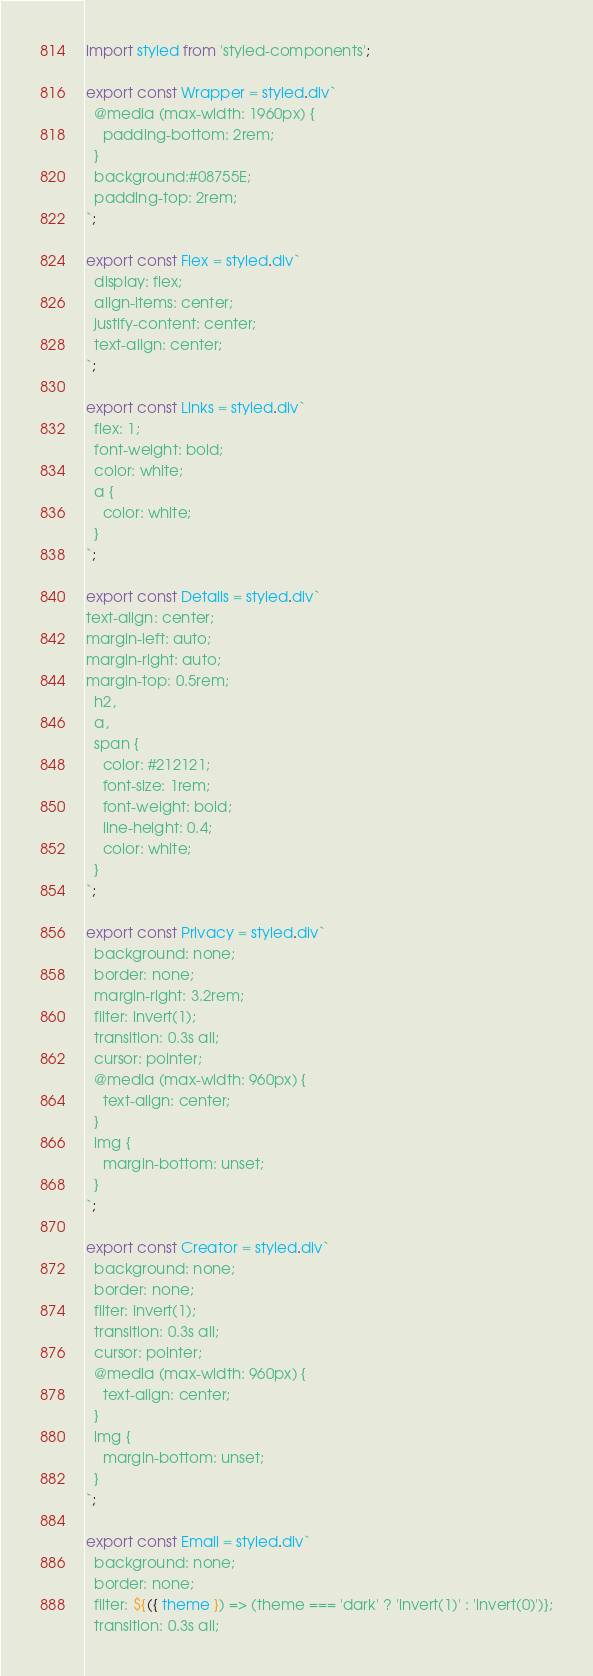Convert code to text. <code><loc_0><loc_0><loc_500><loc_500><_JavaScript_>import styled from 'styled-components';

export const Wrapper = styled.div`
  @media (max-width: 1960px) {
    padding-bottom: 2rem;
  }
  background:#08755E;
  padding-top: 2rem;
`;

export const Flex = styled.div`
  display: flex;
  align-items: center;
  justify-content: center;
  text-align: center;
`;

export const Links = styled.div`
  flex: 1;
  font-weight: bold;
  color: white;
  a {
    color: white;
  }
`;

export const Details = styled.div`
text-align: center;
margin-left: auto;
margin-right: auto;
margin-top: 0.5rem;
  h2,
  a,
  span {
    color: #212121;
    font-size: 1rem;
    font-weight: bold;
    line-height: 0.4;
    color: white;
  }
`;

export const Privacy = styled.div`
  background: none;
  border: none;
  margin-right: 3.2rem;
  filter: invert(1);
  transition: 0.3s all;
  cursor: pointer;
  @media (max-width: 960px) {
    text-align: center;
  }
  img {
    margin-bottom: unset;
  }
`;

export const Creator = styled.div`
  background: none;
  border: none;
  filter: invert(1);
  transition: 0.3s all;
  cursor: pointer;
  @media (max-width: 960px) {
    text-align: center;
  }
  img {
    margin-bottom: unset;
  }
`;

export const Email = styled.div`
  background: none;
  border: none;
  filter: ${({ theme }) => (theme === 'dark' ? 'invert(1)' : 'invert(0)')};
  transition: 0.3s all;</code> 